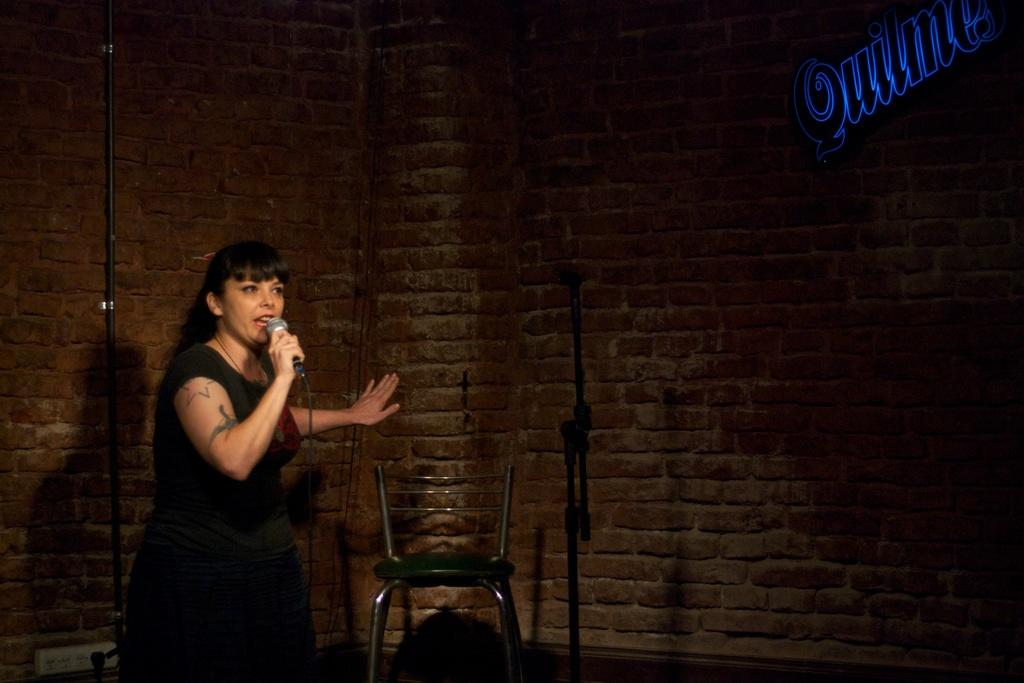Who is the main subject in the image? There is a lady in the image. Where is the lady located in the image? The lady is on the left side of the image. What is the lady holding in her hand? The lady is holding a mic in her hand. What object can be seen in the center of the image? There is a chair in the center of the image. What type of stitch is being used to sew the volcano in the image? There is no stitch or volcano present in the image. How is the power being generated in the image? There is no power generation depicted in the image; it features a lady holding a mic and a chair in the center. 